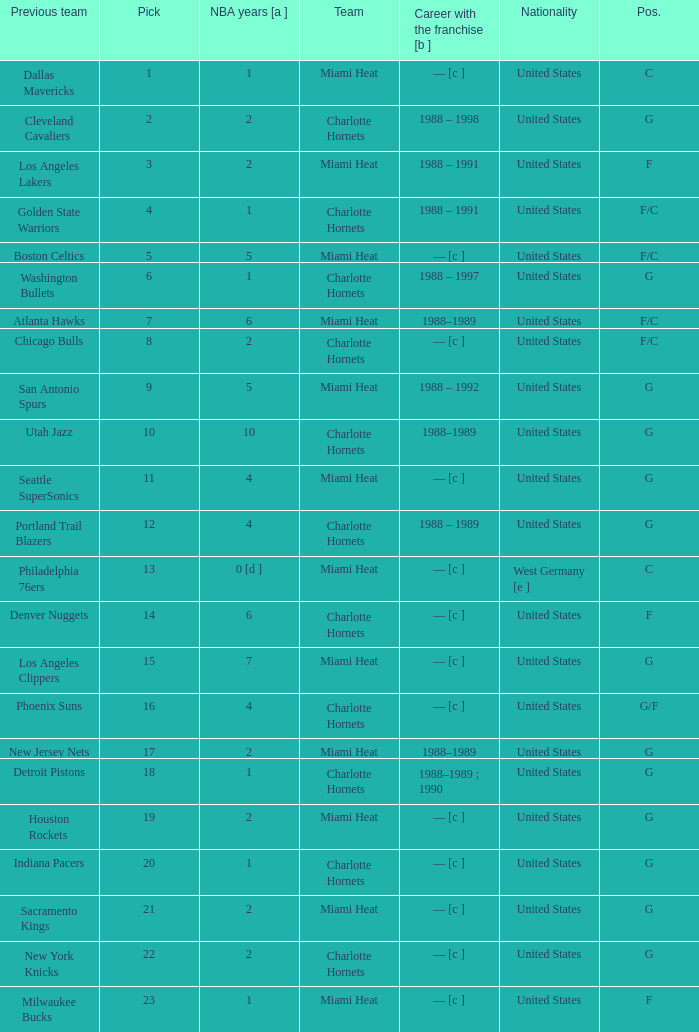What is the team of the player who was previously on the indiana pacers? Charlotte Hornets. 